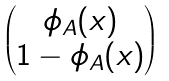<formula> <loc_0><loc_0><loc_500><loc_500>\begin{pmatrix} \phi _ { A } ( x ) \\ 1 - \phi _ { A } ( x ) \end{pmatrix}</formula> 